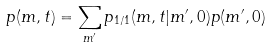<formula> <loc_0><loc_0><loc_500><loc_500>p ( { m } , t ) = \sum _ { { m } ^ { \prime } } p _ { 1 / 1 } ( { m } , t | { m } ^ { \prime } , 0 ) p ( { m } ^ { \prime } , 0 )</formula> 